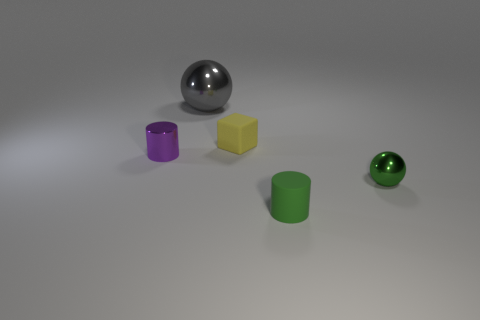Subtract all blue blocks. Subtract all red spheres. How many blocks are left? 1 Add 5 small yellow matte things. How many objects exist? 10 Subtract all cubes. How many objects are left? 4 Subtract all tiny rubber things. Subtract all purple things. How many objects are left? 2 Add 4 green rubber things. How many green rubber things are left? 5 Add 2 tiny yellow rubber cubes. How many tiny yellow rubber cubes exist? 3 Subtract 0 cyan cylinders. How many objects are left? 5 